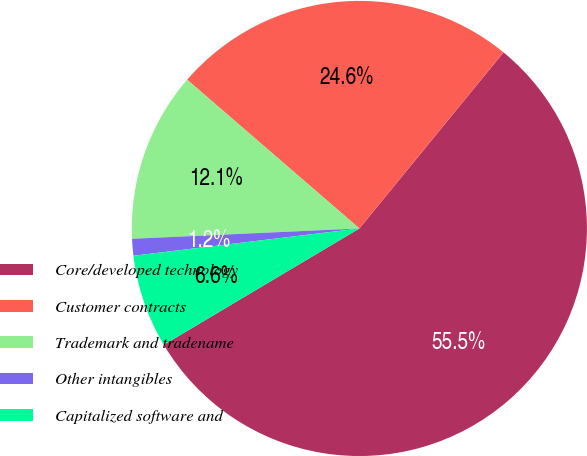Convert chart to OTSL. <chart><loc_0><loc_0><loc_500><loc_500><pie_chart><fcel>Core/developed technology<fcel>Customer contracts<fcel>Trademark and tradename<fcel>Other intangibles<fcel>Capitalized software and<nl><fcel>55.54%<fcel>24.58%<fcel>12.06%<fcel>1.19%<fcel>6.63%<nl></chart> 